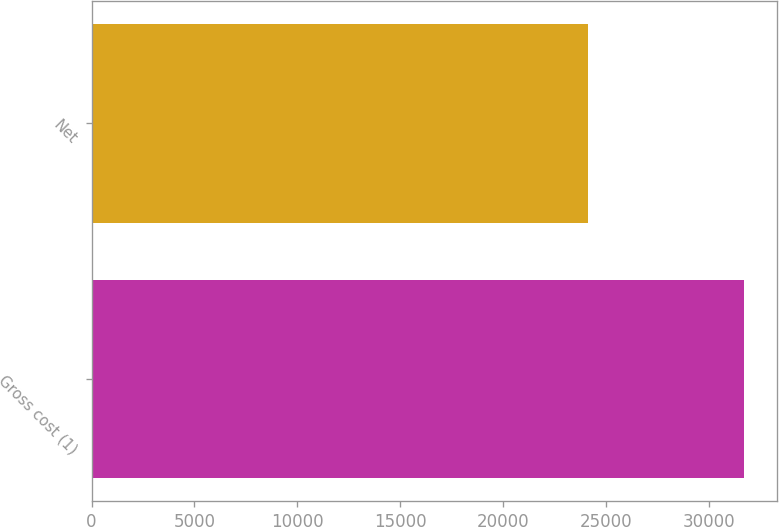Convert chart. <chart><loc_0><loc_0><loc_500><loc_500><bar_chart><fcel>Gross cost (1)<fcel>Net<nl><fcel>31718<fcel>24113<nl></chart> 